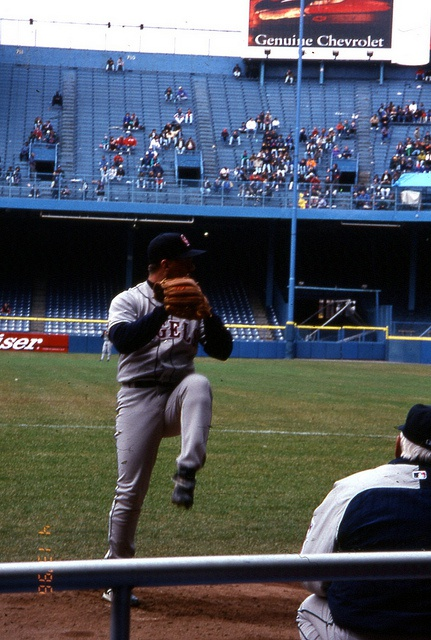Describe the objects in this image and their specific colors. I can see chair in white, gray, black, and blue tones, people in white, black, gray, darkgray, and darkgreen tones, people in white, gray, navy, and black tones, people in white, black, lightgray, darkgray, and gray tones, and chair in white, black, navy, darkgray, and gray tones in this image. 